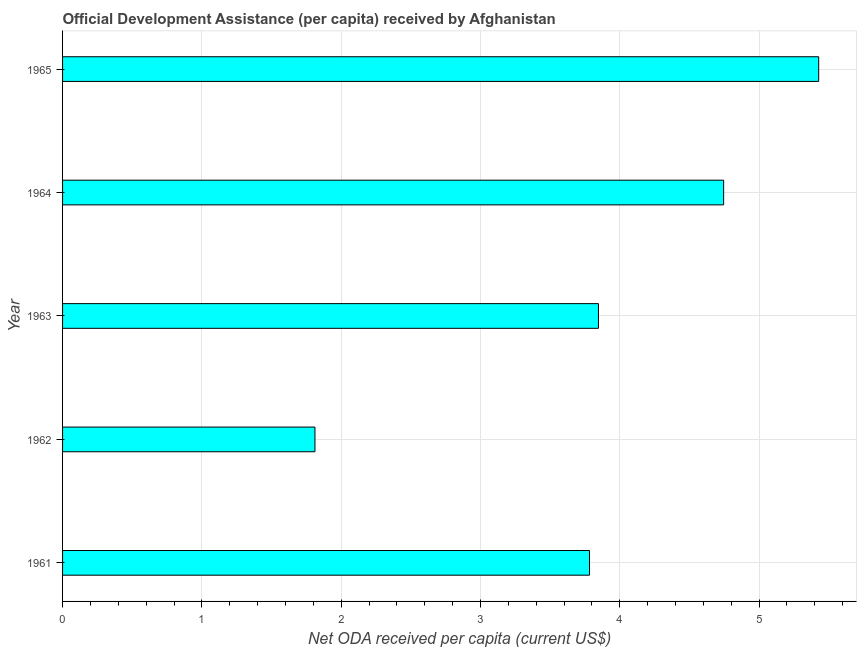What is the title of the graph?
Provide a succinct answer. Official Development Assistance (per capita) received by Afghanistan. What is the label or title of the X-axis?
Provide a succinct answer. Net ODA received per capita (current US$). What is the net oda received per capita in 1962?
Give a very brief answer. 1.81. Across all years, what is the maximum net oda received per capita?
Provide a succinct answer. 5.43. Across all years, what is the minimum net oda received per capita?
Ensure brevity in your answer.  1.81. In which year was the net oda received per capita maximum?
Offer a terse response. 1965. In which year was the net oda received per capita minimum?
Provide a short and direct response. 1962. What is the sum of the net oda received per capita?
Provide a succinct answer. 19.62. What is the difference between the net oda received per capita in 1962 and 1963?
Offer a very short reply. -2.04. What is the average net oda received per capita per year?
Keep it short and to the point. 3.92. What is the median net oda received per capita?
Your answer should be very brief. 3.85. Do a majority of the years between 1964 and 1965 (inclusive) have net oda received per capita greater than 4.8 US$?
Keep it short and to the point. No. What is the ratio of the net oda received per capita in 1961 to that in 1963?
Your answer should be very brief. 0.98. Is the net oda received per capita in 1962 less than that in 1965?
Provide a short and direct response. Yes. Is the difference between the net oda received per capita in 1963 and 1965 greater than the difference between any two years?
Offer a terse response. No. What is the difference between the highest and the second highest net oda received per capita?
Keep it short and to the point. 0.68. Is the sum of the net oda received per capita in 1963 and 1964 greater than the maximum net oda received per capita across all years?
Your answer should be very brief. Yes. What is the difference between the highest and the lowest net oda received per capita?
Offer a terse response. 3.62. In how many years, is the net oda received per capita greater than the average net oda received per capita taken over all years?
Offer a terse response. 2. How many bars are there?
Offer a terse response. 5. Are all the bars in the graph horizontal?
Your answer should be compact. Yes. How many years are there in the graph?
Your answer should be compact. 5. Are the values on the major ticks of X-axis written in scientific E-notation?
Keep it short and to the point. No. What is the Net ODA received per capita (current US$) of 1961?
Ensure brevity in your answer.  3.78. What is the Net ODA received per capita (current US$) in 1962?
Offer a very short reply. 1.81. What is the Net ODA received per capita (current US$) of 1963?
Your answer should be very brief. 3.85. What is the Net ODA received per capita (current US$) in 1964?
Make the answer very short. 4.75. What is the Net ODA received per capita (current US$) of 1965?
Your answer should be very brief. 5.43. What is the difference between the Net ODA received per capita (current US$) in 1961 and 1962?
Give a very brief answer. 1.97. What is the difference between the Net ODA received per capita (current US$) in 1961 and 1963?
Offer a very short reply. -0.06. What is the difference between the Net ODA received per capita (current US$) in 1961 and 1964?
Ensure brevity in your answer.  -0.96. What is the difference between the Net ODA received per capita (current US$) in 1961 and 1965?
Provide a short and direct response. -1.65. What is the difference between the Net ODA received per capita (current US$) in 1962 and 1963?
Provide a short and direct response. -2.04. What is the difference between the Net ODA received per capita (current US$) in 1962 and 1964?
Provide a short and direct response. -2.93. What is the difference between the Net ODA received per capita (current US$) in 1962 and 1965?
Provide a succinct answer. -3.62. What is the difference between the Net ODA received per capita (current US$) in 1963 and 1964?
Give a very brief answer. -0.9. What is the difference between the Net ODA received per capita (current US$) in 1963 and 1965?
Ensure brevity in your answer.  -1.58. What is the difference between the Net ODA received per capita (current US$) in 1964 and 1965?
Offer a terse response. -0.68. What is the ratio of the Net ODA received per capita (current US$) in 1961 to that in 1962?
Give a very brief answer. 2.09. What is the ratio of the Net ODA received per capita (current US$) in 1961 to that in 1963?
Offer a terse response. 0.98. What is the ratio of the Net ODA received per capita (current US$) in 1961 to that in 1964?
Offer a terse response. 0.8. What is the ratio of the Net ODA received per capita (current US$) in 1961 to that in 1965?
Provide a short and direct response. 0.7. What is the ratio of the Net ODA received per capita (current US$) in 1962 to that in 1963?
Ensure brevity in your answer.  0.47. What is the ratio of the Net ODA received per capita (current US$) in 1962 to that in 1964?
Your answer should be very brief. 0.38. What is the ratio of the Net ODA received per capita (current US$) in 1962 to that in 1965?
Your response must be concise. 0.33. What is the ratio of the Net ODA received per capita (current US$) in 1963 to that in 1964?
Make the answer very short. 0.81. What is the ratio of the Net ODA received per capita (current US$) in 1963 to that in 1965?
Give a very brief answer. 0.71. What is the ratio of the Net ODA received per capita (current US$) in 1964 to that in 1965?
Your answer should be very brief. 0.87. 